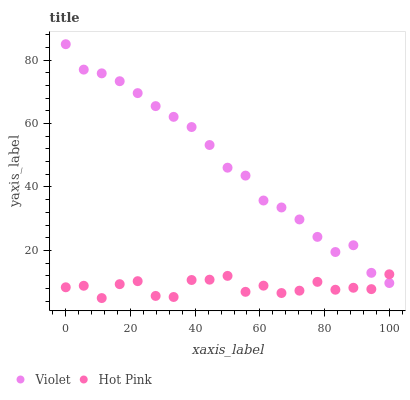Does Hot Pink have the minimum area under the curve?
Answer yes or no. Yes. Does Violet have the maximum area under the curve?
Answer yes or no. Yes. Does Violet have the minimum area under the curve?
Answer yes or no. No. Is Violet the smoothest?
Answer yes or no. Yes. Is Hot Pink the roughest?
Answer yes or no. Yes. Is Violet the roughest?
Answer yes or no. No. Does Hot Pink have the lowest value?
Answer yes or no. Yes. Does Violet have the lowest value?
Answer yes or no. No. Does Violet have the highest value?
Answer yes or no. Yes. Does Hot Pink intersect Violet?
Answer yes or no. Yes. Is Hot Pink less than Violet?
Answer yes or no. No. Is Hot Pink greater than Violet?
Answer yes or no. No. 